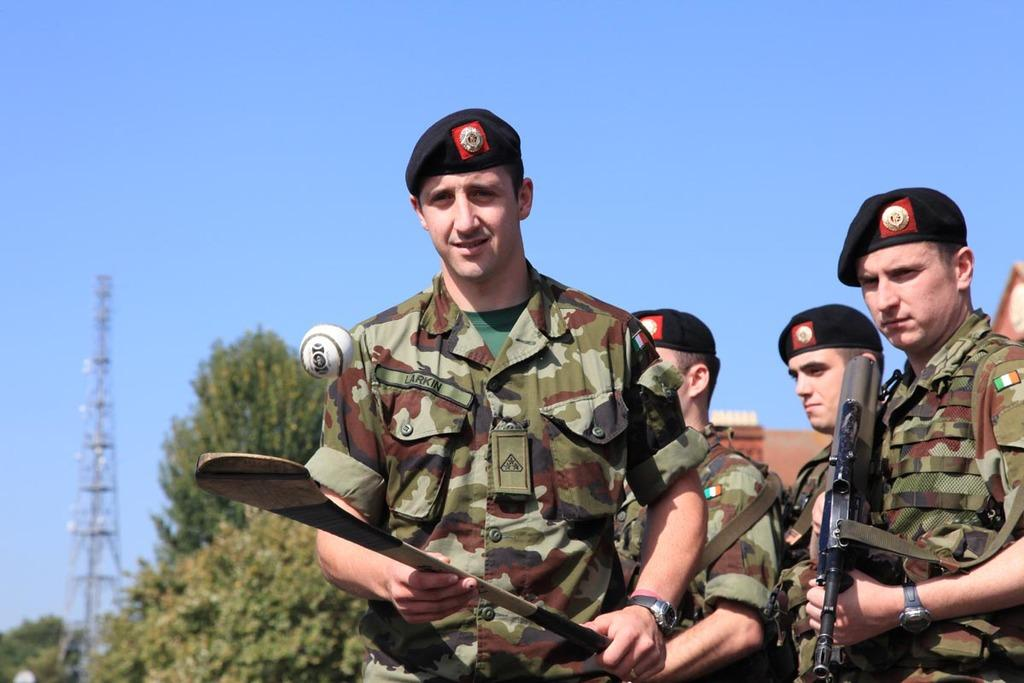What type of people are in the image? There are military officers in the image. What is one of the military officers holding? One of the military officers is holding a gun. What is the other person holding, and what can be seen in the image related to that object? Another person is holding a bat, and there is a bat visible in the image. What type of natural environment can be seen in the image? There are trees in the image. What type of structures can be seen in the image? There are towers and a house in the image. What is visible in the sky in the image? The sky is visible in the image. What type of berry is growing on the legs of the military officers in the image? There are no berries visible in the image, and the military officers' legs are not mentioned as having any growths or objects on them. 